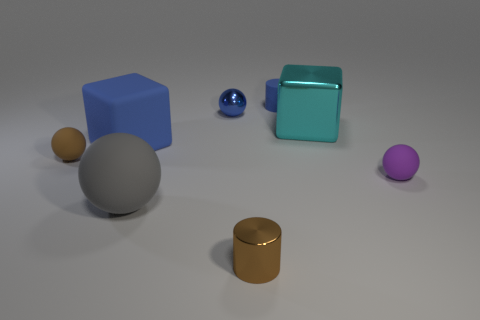Subtract all small brown spheres. How many spheres are left? 3 Add 1 big red rubber cylinders. How many objects exist? 9 Subtract all gray balls. How many balls are left? 3 Subtract 1 cubes. How many cubes are left? 1 Subtract all cubes. How many objects are left? 6 Subtract all gray blocks. Subtract all brown cylinders. How many blocks are left? 2 Subtract all blue rubber blocks. Subtract all small purple things. How many objects are left? 6 Add 8 large gray things. How many large gray things are left? 9 Add 6 big metallic things. How many big metallic things exist? 7 Subtract 1 purple balls. How many objects are left? 7 